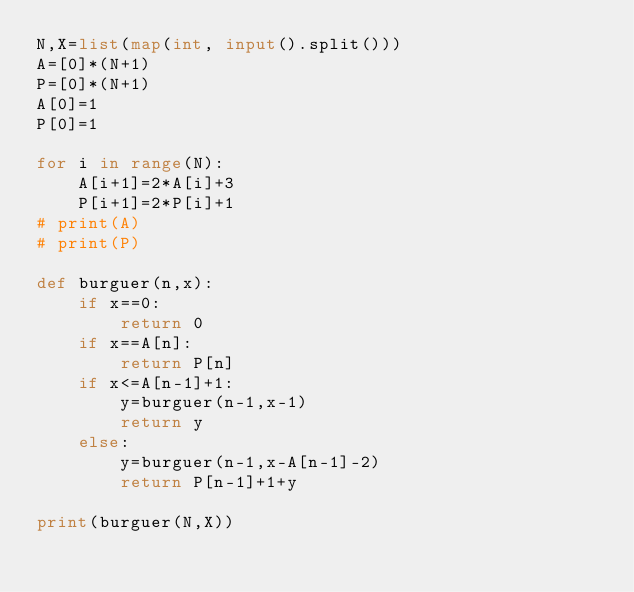<code> <loc_0><loc_0><loc_500><loc_500><_Python_>N,X=list(map(int, input().split()))
A=[0]*(N+1)
P=[0]*(N+1)
A[0]=1
P[0]=1

for i in range(N):
    A[i+1]=2*A[i]+3
    P[i+1]=2*P[i]+1
# print(A)
# print(P)

def burguer(n,x):
    if x==0:
        return 0
    if x==A[n]:
        return P[n]
    if x<=A[n-1]+1:
        y=burguer(n-1,x-1)
        return y
    else:
        y=burguer(n-1,x-A[n-1]-2)
        return P[n-1]+1+y

print(burguer(N,X))</code> 